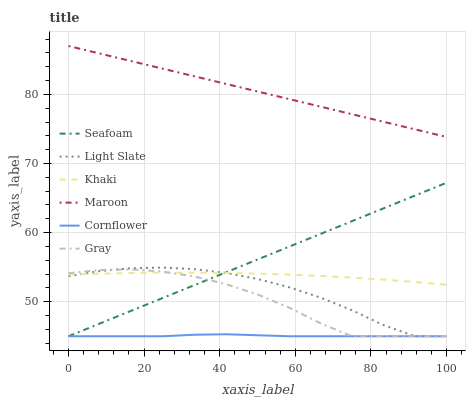Does Khaki have the minimum area under the curve?
Answer yes or no. No. Does Khaki have the maximum area under the curve?
Answer yes or no. No. Is Khaki the smoothest?
Answer yes or no. No. Is Khaki the roughest?
Answer yes or no. No. Does Khaki have the lowest value?
Answer yes or no. No. Does Khaki have the highest value?
Answer yes or no. No. Is Khaki less than Maroon?
Answer yes or no. Yes. Is Maroon greater than Gray?
Answer yes or no. Yes. Does Khaki intersect Maroon?
Answer yes or no. No. 